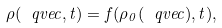Convert formula to latex. <formula><loc_0><loc_0><loc_500><loc_500>\rho ( \ q v e c , t ) = f ( \rho _ { 0 } ( \ q v e c ) , t ) ,</formula> 